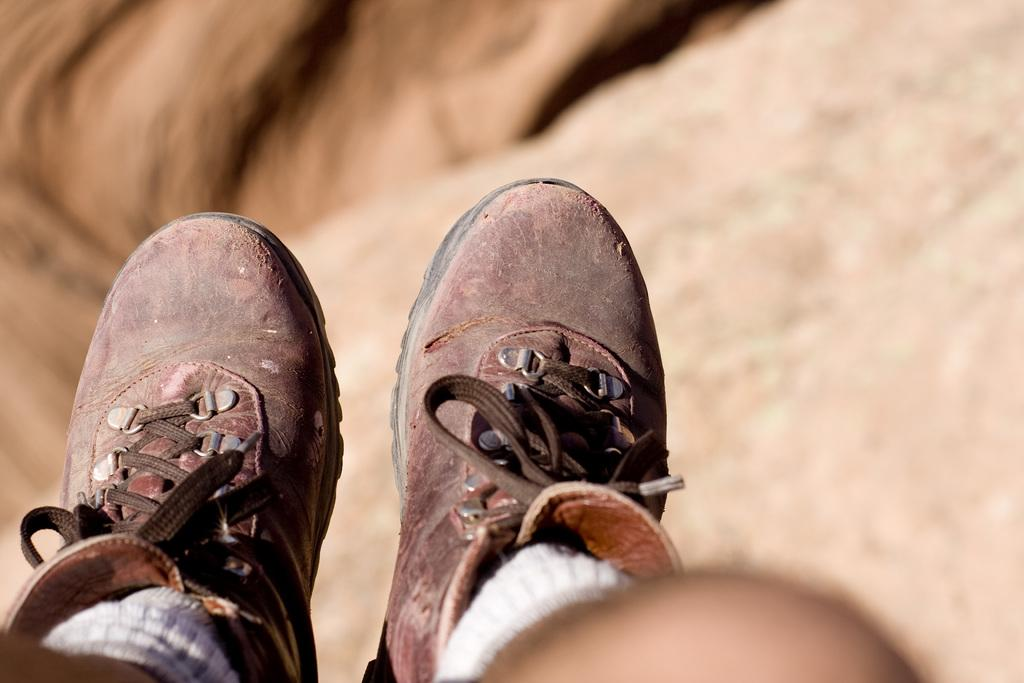What can be seen at the bottom of the image? Human legs wearing footwear are visible at the bottom of the image. Can you describe the background of the image? The background of the image is blurred. What type of egg is being cooked in the image? There is no egg or cooking activity present in the image. 